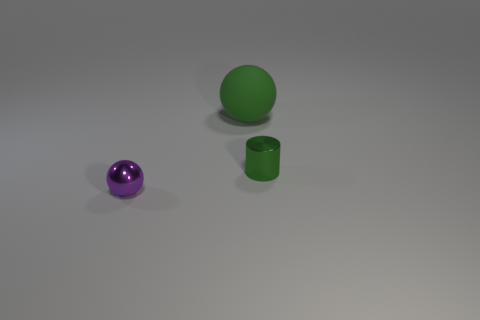Add 3 small green metallic cylinders. How many objects exist? 6 Subtract all balls. How many objects are left? 1 Add 2 small metal spheres. How many small metal spheres exist? 3 Subtract 0 brown spheres. How many objects are left? 3 Subtract all small purple shiny spheres. Subtract all large green balls. How many objects are left? 1 Add 2 tiny objects. How many tiny objects are left? 4 